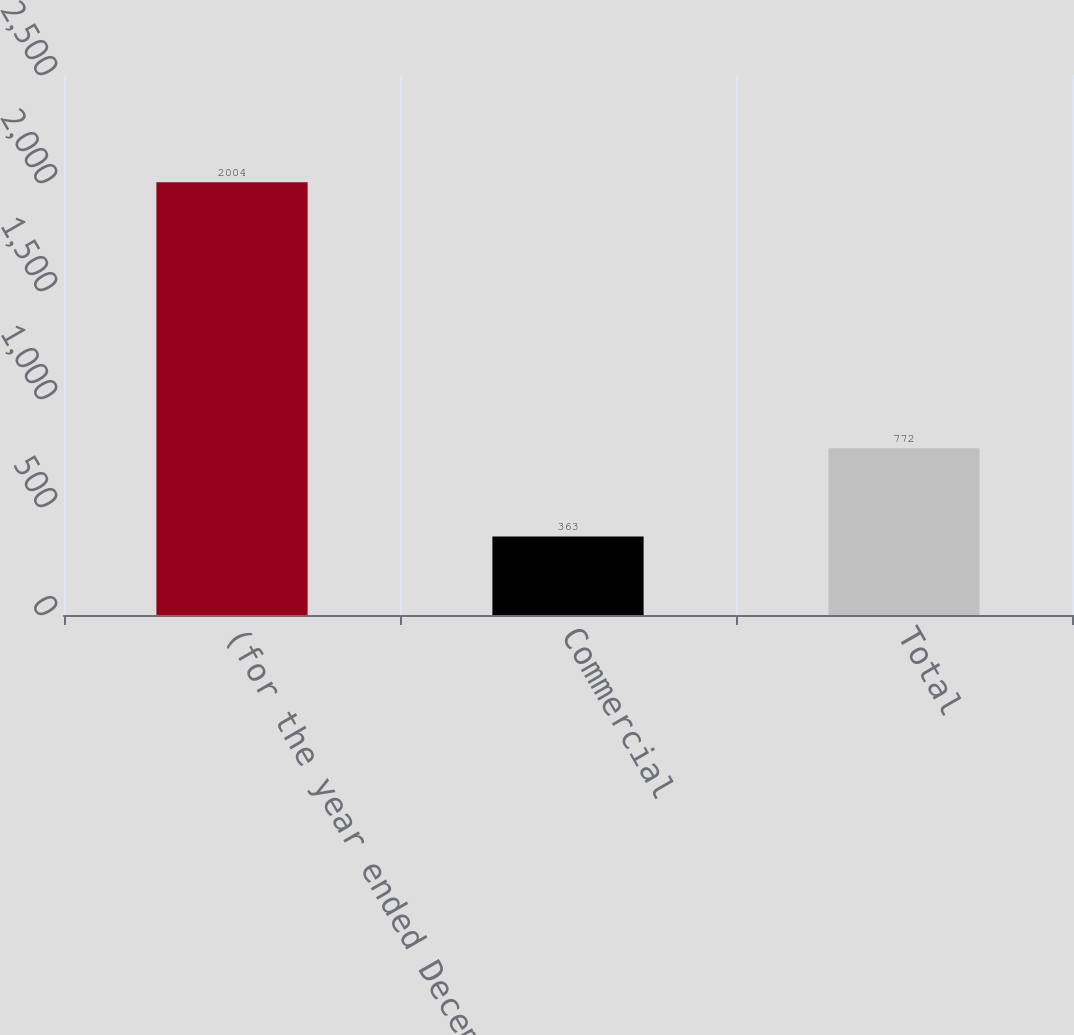<chart> <loc_0><loc_0><loc_500><loc_500><bar_chart><fcel>(for the year ended December<fcel>Commercial<fcel>Total<nl><fcel>2004<fcel>363<fcel>772<nl></chart> 